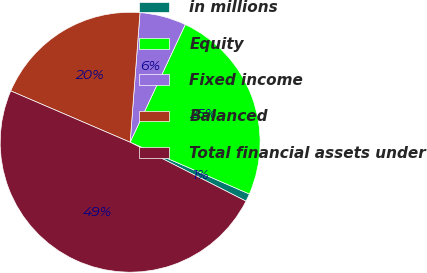Convert chart. <chart><loc_0><loc_0><loc_500><loc_500><pie_chart><fcel>in millions<fcel>Equity<fcel>Fixed income<fcel>Balanced<fcel>Total financial assets under<nl><fcel>0.97%<fcel>24.54%<fcel>5.77%<fcel>19.74%<fcel>48.97%<nl></chart> 